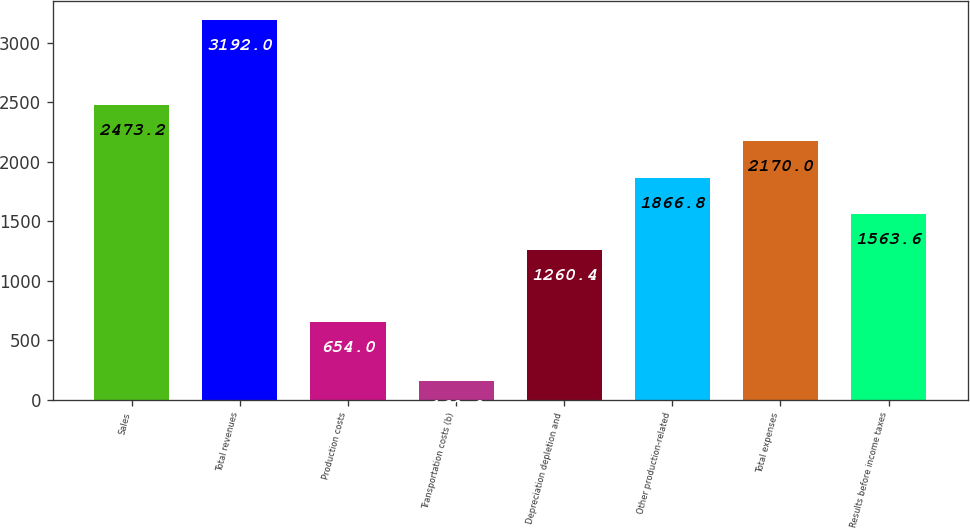Convert chart to OTSL. <chart><loc_0><loc_0><loc_500><loc_500><bar_chart><fcel>Sales<fcel>Total revenues<fcel>Production costs<fcel>Transportation costs (b)<fcel>Depreciation depletion and<fcel>Other production-related<fcel>Total expenses<fcel>Results before income taxes<nl><fcel>2473.2<fcel>3192<fcel>654<fcel>160<fcel>1260.4<fcel>1866.8<fcel>2170<fcel>1563.6<nl></chart> 